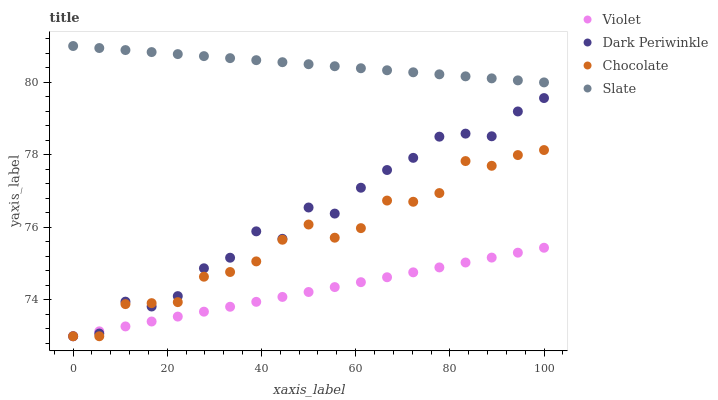Does Violet have the minimum area under the curve?
Answer yes or no. Yes. Does Slate have the maximum area under the curve?
Answer yes or no. Yes. Does Chocolate have the minimum area under the curve?
Answer yes or no. No. Does Chocolate have the maximum area under the curve?
Answer yes or no. No. Is Slate the smoothest?
Answer yes or no. Yes. Is Dark Periwinkle the roughest?
Answer yes or no. Yes. Is Chocolate the smoothest?
Answer yes or no. No. Is Chocolate the roughest?
Answer yes or no. No. Does Chocolate have the lowest value?
Answer yes or no. Yes. Does Slate have the highest value?
Answer yes or no. Yes. Does Chocolate have the highest value?
Answer yes or no. No. Is Chocolate less than Slate?
Answer yes or no. Yes. Is Slate greater than Dark Periwinkle?
Answer yes or no. Yes. Does Dark Periwinkle intersect Violet?
Answer yes or no. Yes. Is Dark Periwinkle less than Violet?
Answer yes or no. No. Is Dark Periwinkle greater than Violet?
Answer yes or no. No. Does Chocolate intersect Slate?
Answer yes or no. No. 